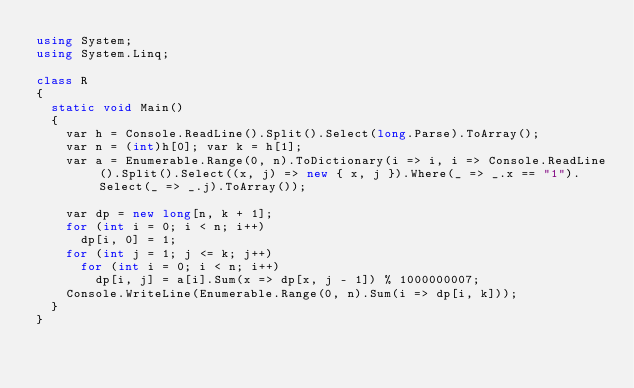<code> <loc_0><loc_0><loc_500><loc_500><_C#_>using System;
using System.Linq;

class R
{
	static void Main()
	{
		var h = Console.ReadLine().Split().Select(long.Parse).ToArray();
		var n = (int)h[0]; var k = h[1];
		var a = Enumerable.Range(0, n).ToDictionary(i => i, i => Console.ReadLine().Split().Select((x, j) => new { x, j }).Where(_ => _.x == "1").Select(_ => _.j).ToArray());

		var dp = new long[n, k + 1];
		for (int i = 0; i < n; i++)
			dp[i, 0] = 1;
		for (int j = 1; j <= k; j++)
			for (int i = 0; i < n; i++)
				dp[i, j] = a[i].Sum(x => dp[x, j - 1]) % 1000000007;
		Console.WriteLine(Enumerable.Range(0, n).Sum(i => dp[i, k]));
	}
}
</code> 